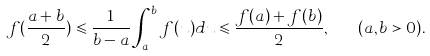<formula> <loc_0><loc_0><loc_500><loc_500>f ( \frac { a + b } { 2 } ) \leqslant \frac { 1 } { b - a } \int ^ { b } _ { a } f ( u ) d u \leqslant \frac { f ( a ) + f ( b ) } { 2 } , \quad ( a , b > 0 ) .</formula> 